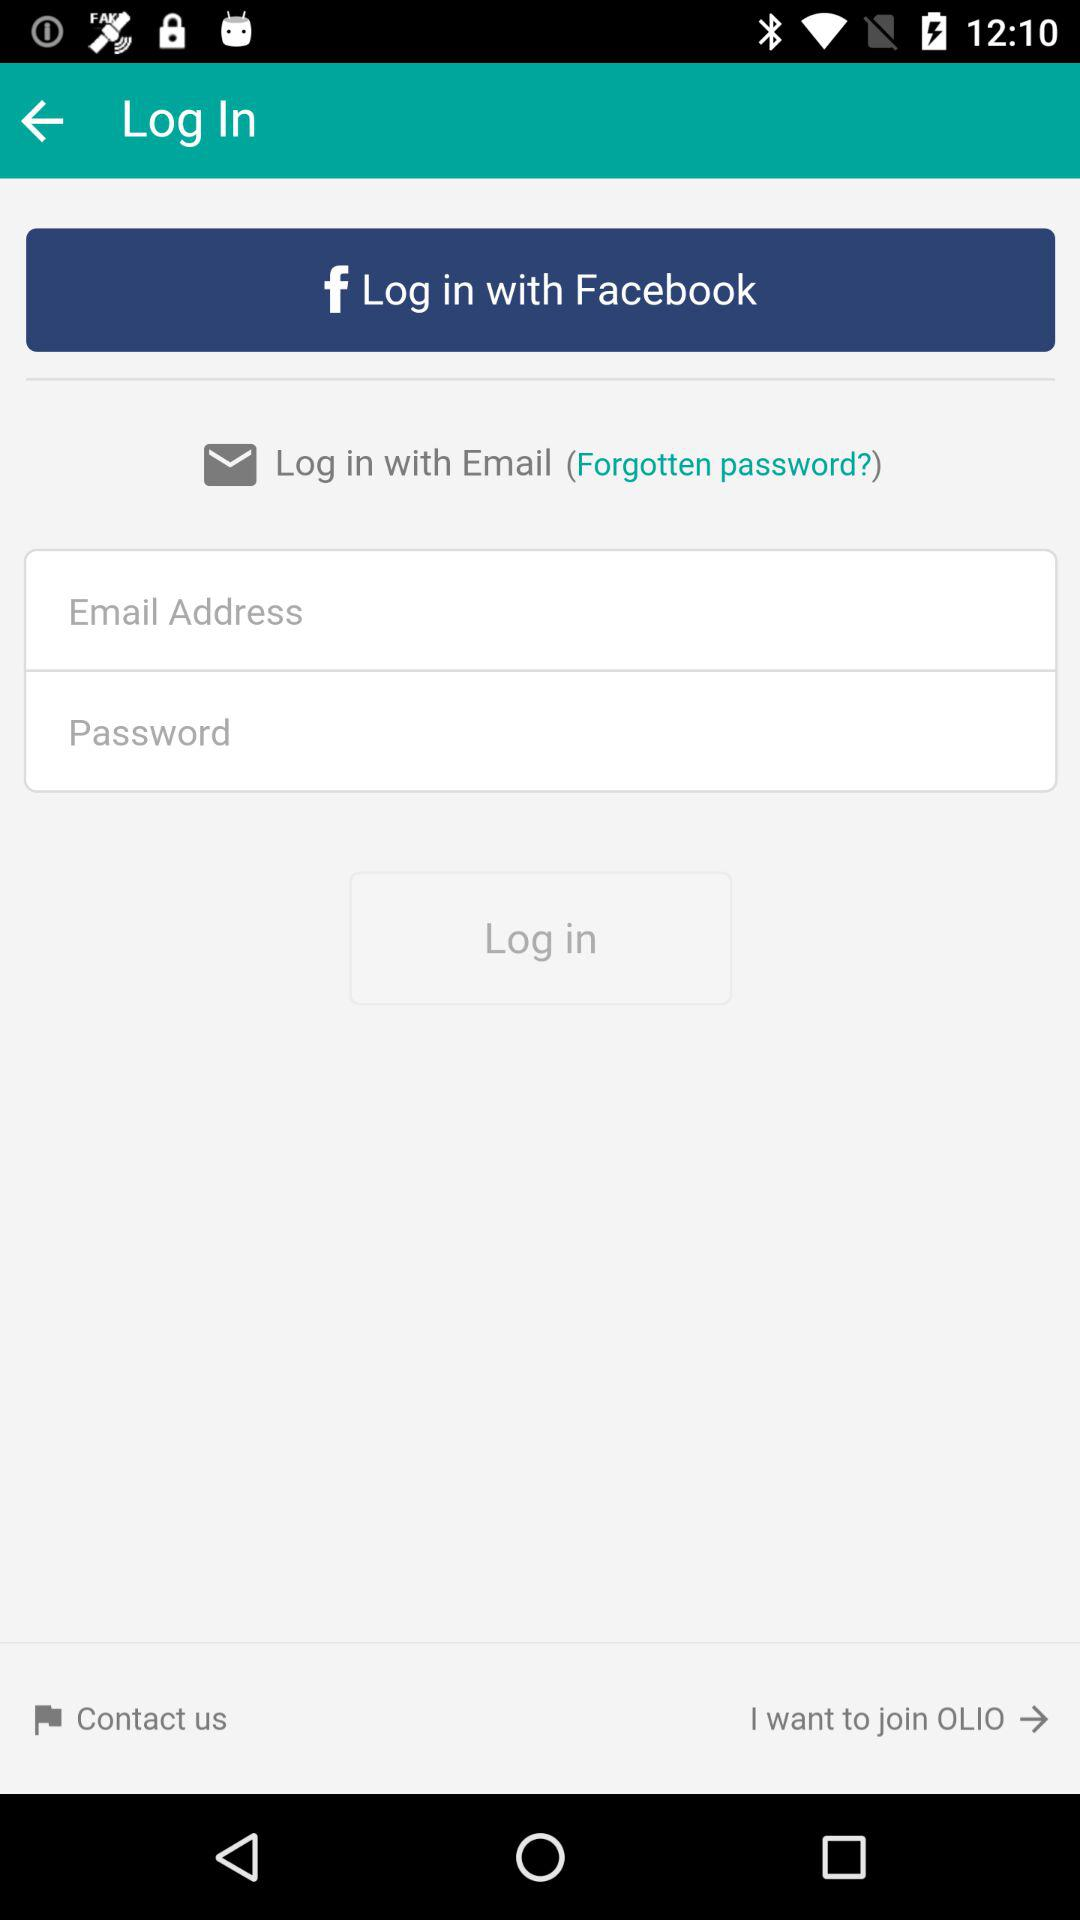How many text fields are there in the login form?
Answer the question using a single word or phrase. 2 